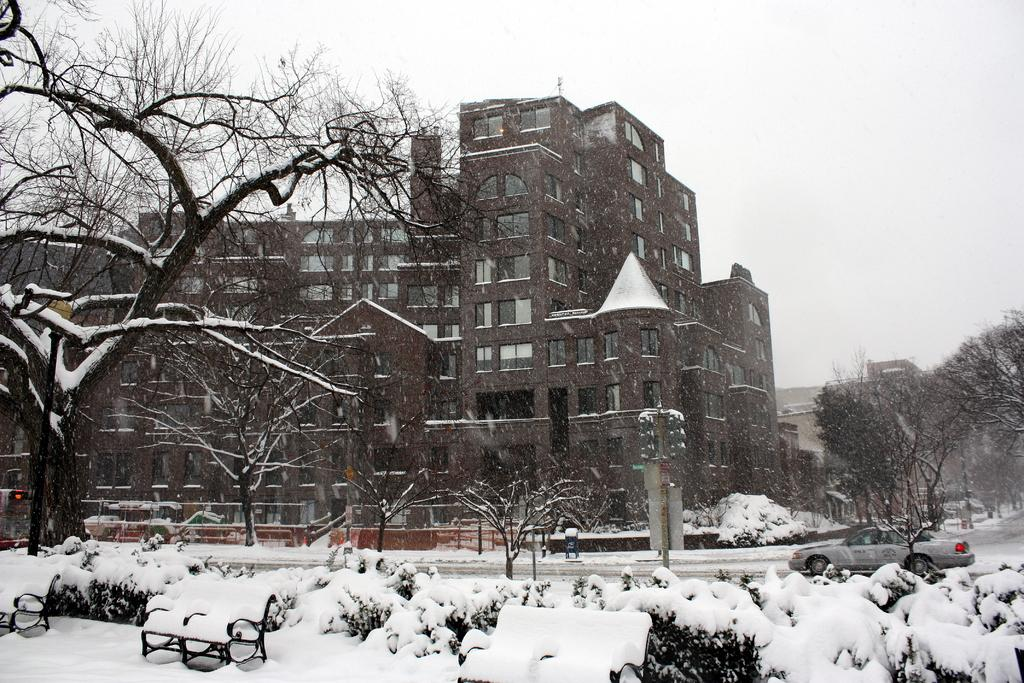What type of structures can be seen in the image? There are buildings in the image. What type of natural elements are present in the image? There are trees and plants in the image. What type of seating is available in the image? There are benches in the image. What type of transportation is visible in the image? There is a car in the image. What type of infrastructure is present in the image? There are poles and traffic signals in the image. What type of weather condition is depicted in the image? There is snow in the image. What can be seen in the background of the image? The sky is visible in the background of the image. Where is the farm located in the image? There is no farm present in the image. What type of quilt is draped over the car in the image? There is no quilt present in the image. 